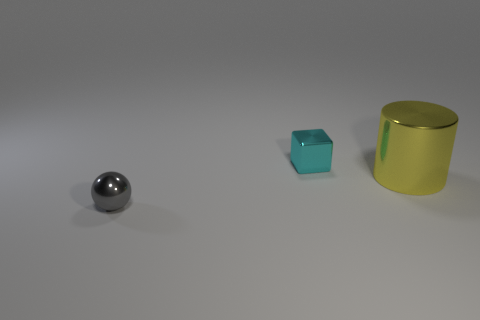Is there anything else that is the same shape as the large metallic object?
Provide a short and direct response. No. The small ball has what color?
Give a very brief answer. Gray. There is a small metal thing that is behind the object in front of the large shiny cylinder; what shape is it?
Your answer should be very brief. Cube. Is there a gray thing made of the same material as the tiny cyan cube?
Keep it short and to the point. Yes. Is the size of the object in front of the yellow object the same as the large thing?
Ensure brevity in your answer.  No. How many gray objects are spheres or cylinders?
Your answer should be compact. 1. There is a tiny thing that is on the left side of the cyan block; what is it made of?
Keep it short and to the point. Metal. There is a tiny shiny object to the right of the tiny gray ball; how many metallic things are left of it?
Your response must be concise. 1. What number of large metallic cylinders are there?
Your answer should be compact. 1. There is a tiny thing that is in front of the large yellow metal cylinder; what color is it?
Give a very brief answer. Gray. 